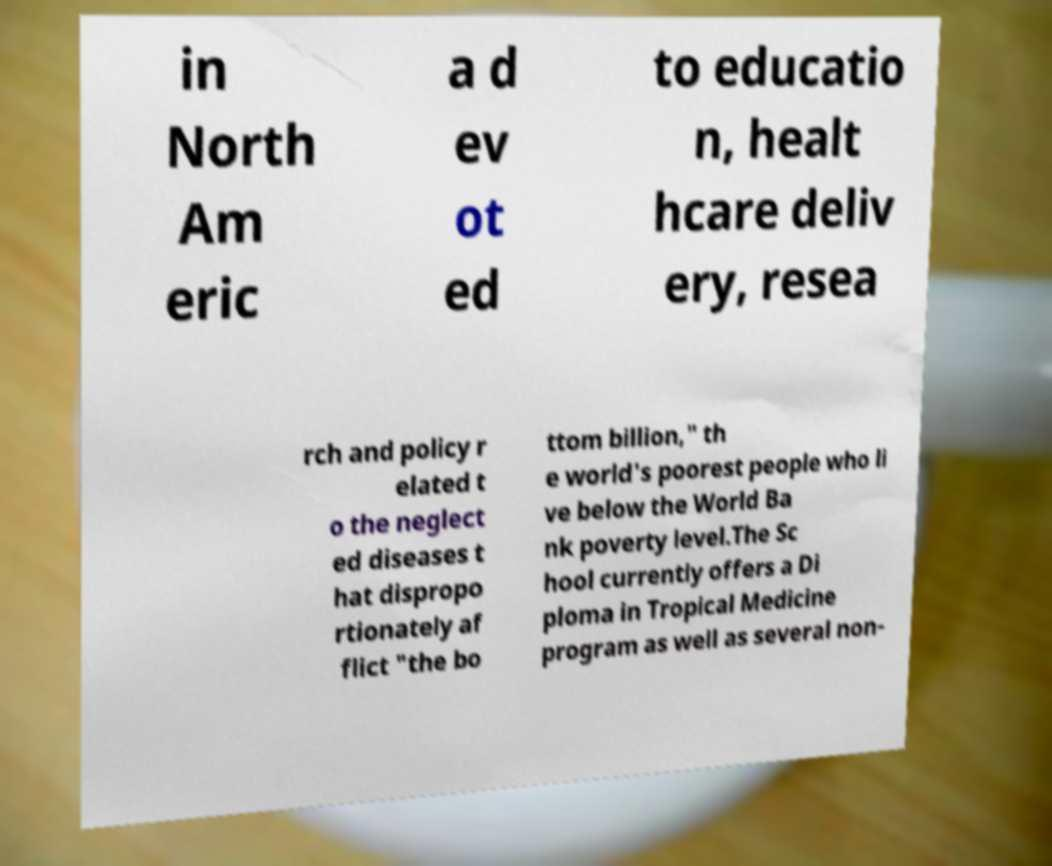Please identify and transcribe the text found in this image. in North Am eric a d ev ot ed to educatio n, healt hcare deliv ery, resea rch and policy r elated t o the neglect ed diseases t hat dispropo rtionately af flict "the bo ttom billion," th e world's poorest people who li ve below the World Ba nk poverty level.The Sc hool currently offers a Di ploma in Tropical Medicine program as well as several non- 